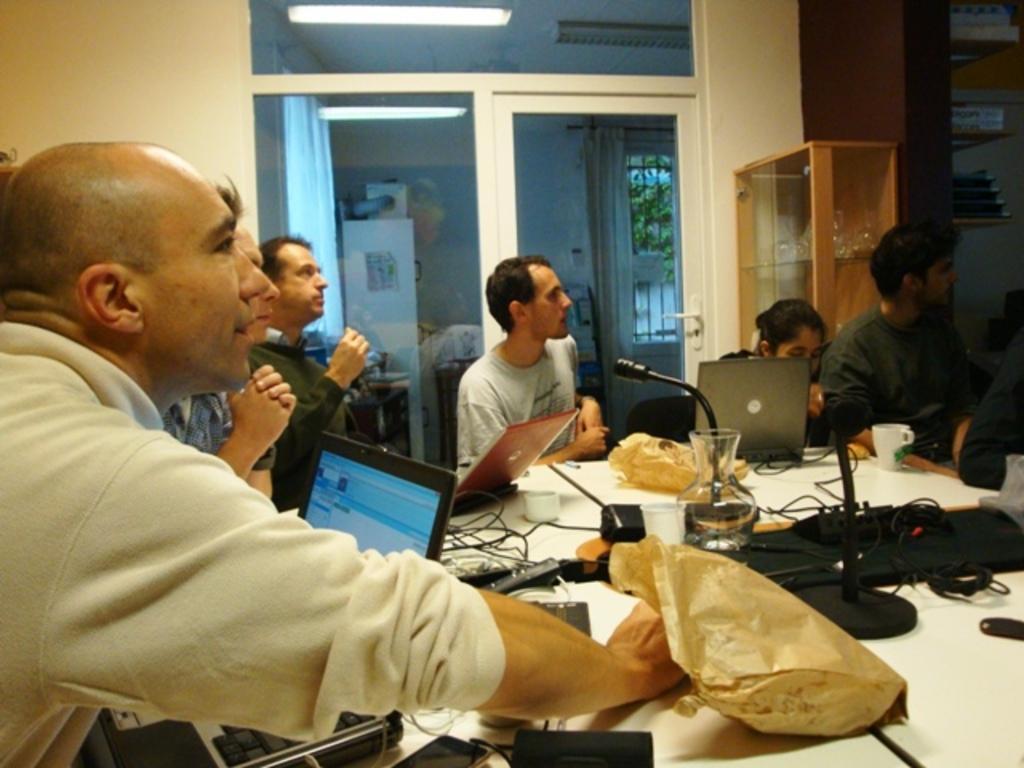Could you give a brief overview of what you see in this image? In this picture we can see a few covers, laptop's, microphone, wires, cups, glass and other objects on the table. We can see a few people from left to right. There are glass objects visible in the glass cupboard. We can see a few things on the shelves on the right side. We can see a glass object. Through this glass object, we can see a few objects at the back. There is a tree visible in the background. 